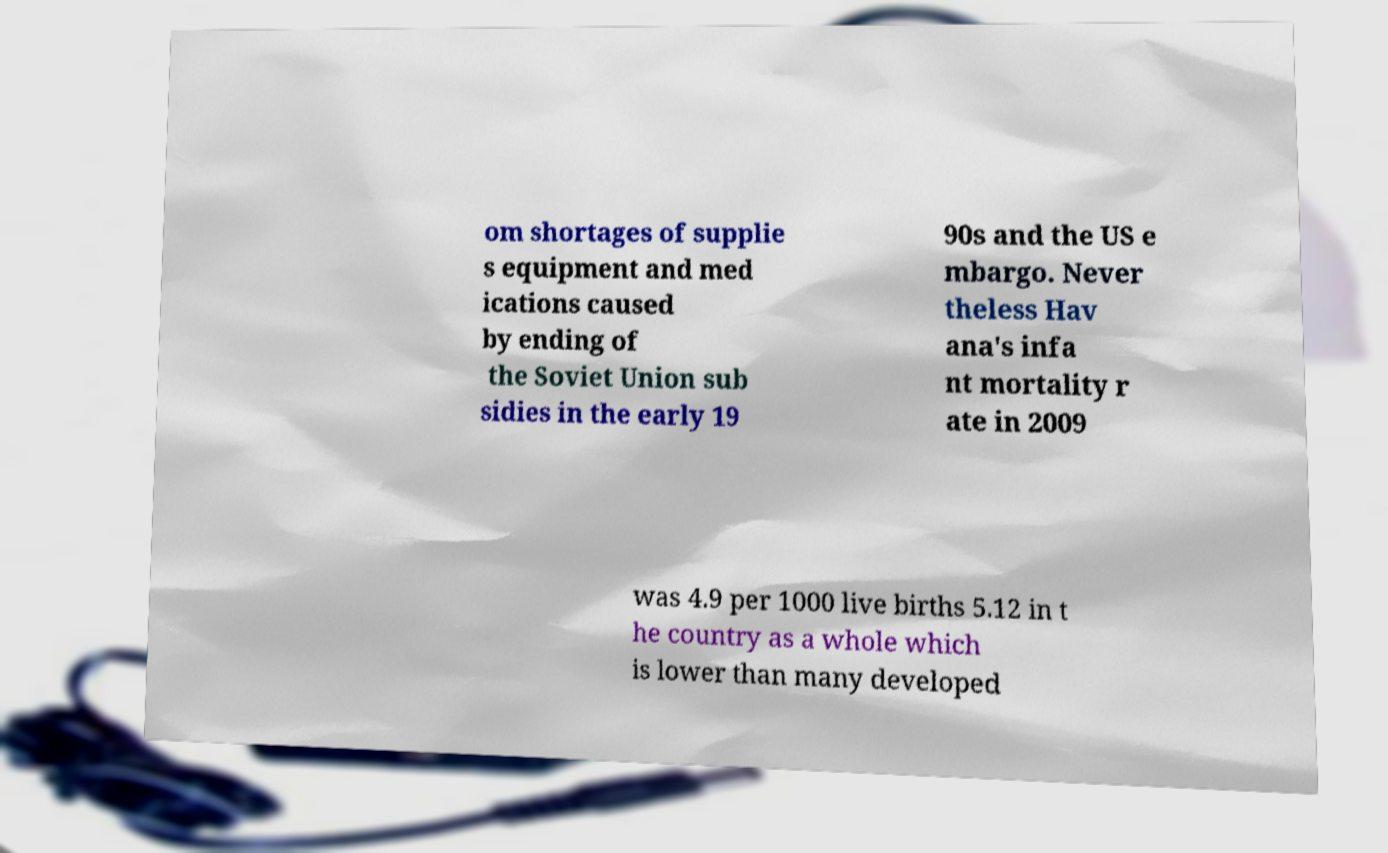Can you read and provide the text displayed in the image?This photo seems to have some interesting text. Can you extract and type it out for me? om shortages of supplie s equipment and med ications caused by ending of the Soviet Union sub sidies in the early 19 90s and the US e mbargo. Never theless Hav ana's infa nt mortality r ate in 2009 was 4.9 per 1000 live births 5.12 in t he country as a whole which is lower than many developed 